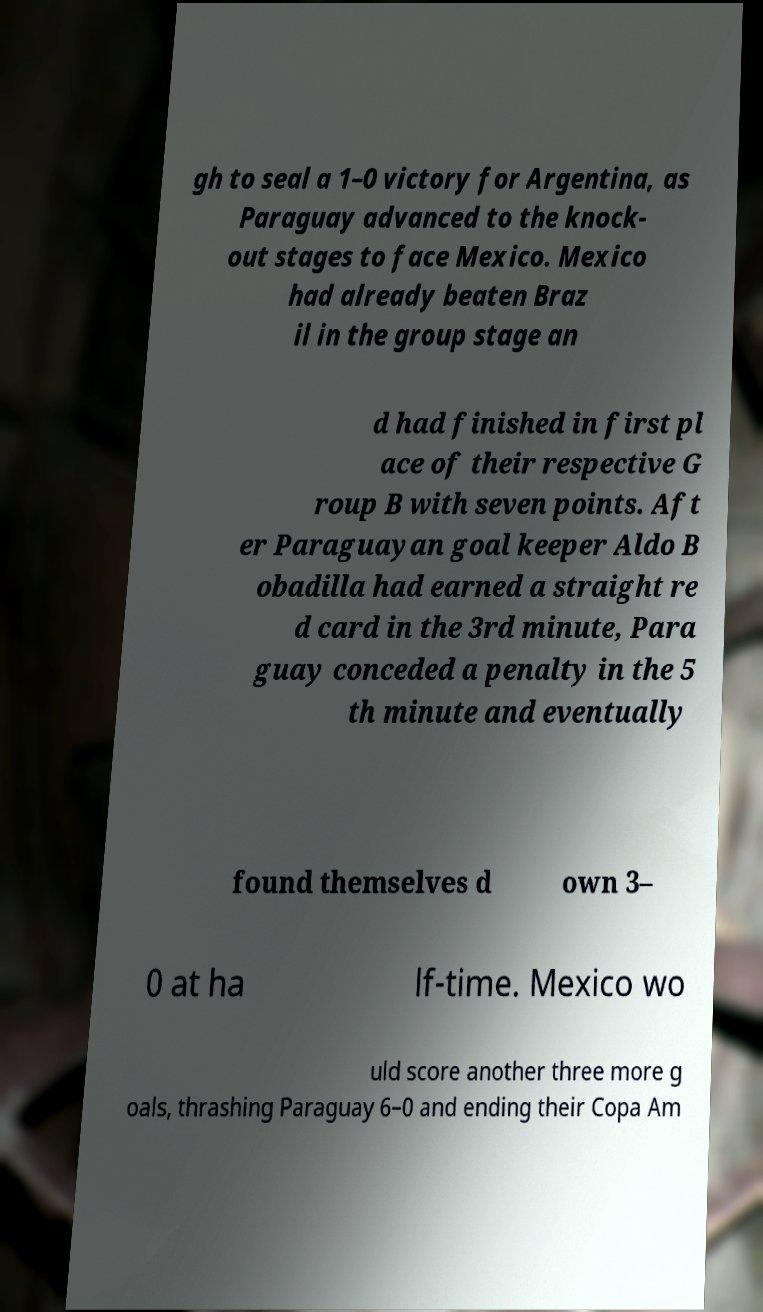There's text embedded in this image that I need extracted. Can you transcribe it verbatim? gh to seal a 1–0 victory for Argentina, as Paraguay advanced to the knock- out stages to face Mexico. Mexico had already beaten Braz il in the group stage an d had finished in first pl ace of their respective G roup B with seven points. Aft er Paraguayan goal keeper Aldo B obadilla had earned a straight re d card in the 3rd minute, Para guay conceded a penalty in the 5 th minute and eventually found themselves d own 3– 0 at ha lf-time. Mexico wo uld score another three more g oals, thrashing Paraguay 6–0 and ending their Copa Am 